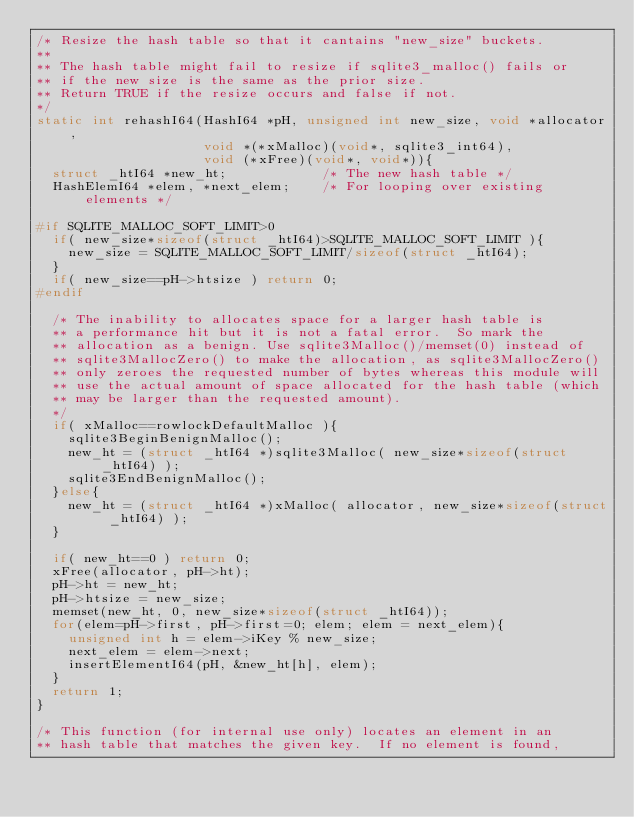<code> <loc_0><loc_0><loc_500><loc_500><_C_>/* Resize the hash table so that it cantains "new_size" buckets.
**
** The hash table might fail to resize if sqlite3_malloc() fails or
** if the new size is the same as the prior size.
** Return TRUE if the resize occurs and false if not.
*/
static int rehashI64(HashI64 *pH, unsigned int new_size, void *allocator,
                     void *(*xMalloc)(void*, sqlite3_int64),
                     void (*xFree)(void*, void*)){
  struct _htI64 *new_ht;            /* The new hash table */
  HashElemI64 *elem, *next_elem;    /* For looping over existing elements */

#if SQLITE_MALLOC_SOFT_LIMIT>0
  if( new_size*sizeof(struct _htI64)>SQLITE_MALLOC_SOFT_LIMIT ){
    new_size = SQLITE_MALLOC_SOFT_LIMIT/sizeof(struct _htI64);
  }
  if( new_size==pH->htsize ) return 0;
#endif

  /* The inability to allocates space for a larger hash table is
  ** a performance hit but it is not a fatal error.  So mark the
  ** allocation as a benign. Use sqlite3Malloc()/memset(0) instead of 
  ** sqlite3MallocZero() to make the allocation, as sqlite3MallocZero()
  ** only zeroes the requested number of bytes whereas this module will
  ** use the actual amount of space allocated for the hash table (which
  ** may be larger than the requested amount).
  */
  if( xMalloc==rowlockDefaultMalloc ){
    sqlite3BeginBenignMalloc();
    new_ht = (struct _htI64 *)sqlite3Malloc( new_size*sizeof(struct _htI64) );
    sqlite3EndBenignMalloc();
  }else{
    new_ht = (struct _htI64 *)xMalloc( allocator, new_size*sizeof(struct _htI64) );
  }

  if( new_ht==0 ) return 0;
  xFree(allocator, pH->ht);
  pH->ht = new_ht;
  pH->htsize = new_size;
  memset(new_ht, 0, new_size*sizeof(struct _htI64));
  for(elem=pH->first, pH->first=0; elem; elem = next_elem){
    unsigned int h = elem->iKey % new_size;
    next_elem = elem->next;
    insertElementI64(pH, &new_ht[h], elem);
  }
  return 1;
}

/* This function (for internal use only) locates an element in an
** hash table that matches the given key.  If no element is found,</code> 